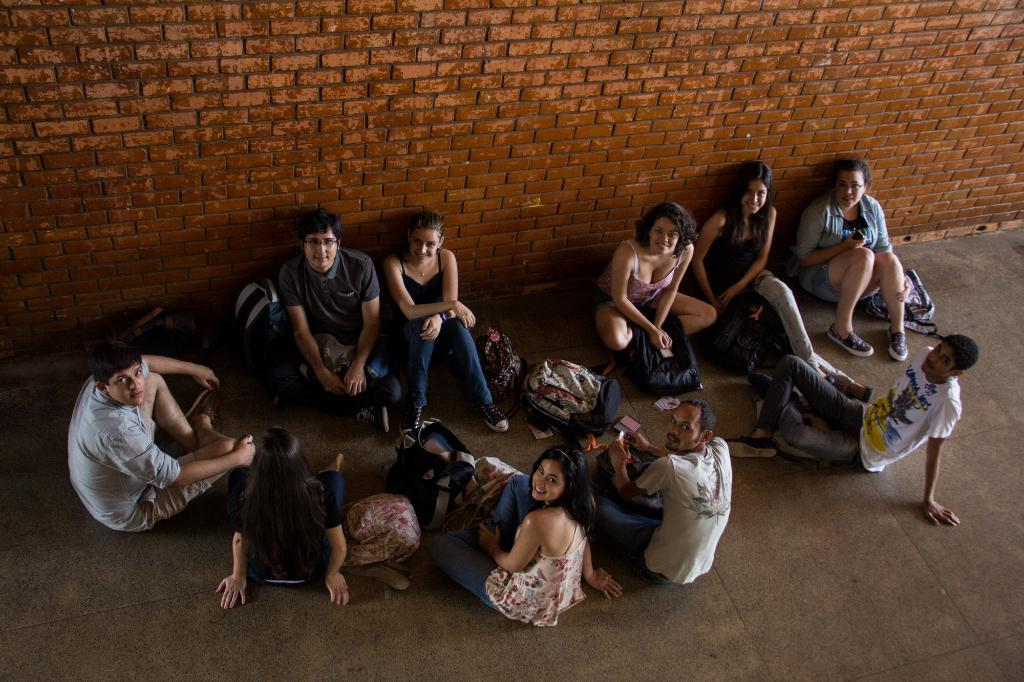What are the people in the image doing? There is a group of people sitting on the ground in the image. What else can be seen on the ground besides the people? There are bags and other objects on the ground. What is the background of the image? There is a brick wall in the image. What type of canvas is being used to create a painting in the image? There is no canvas or painting present in the image; it features a group of people sitting on the ground with bags and other objects on the ground, and a brick wall in the background. 